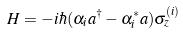Convert formula to latex. <formula><loc_0><loc_0><loc_500><loc_500>H = - i \hbar { ( } \alpha _ { i } a ^ { \dagger } - \alpha _ { i } ^ { * } a ) \sigma _ { z } ^ { ( i ) }</formula> 